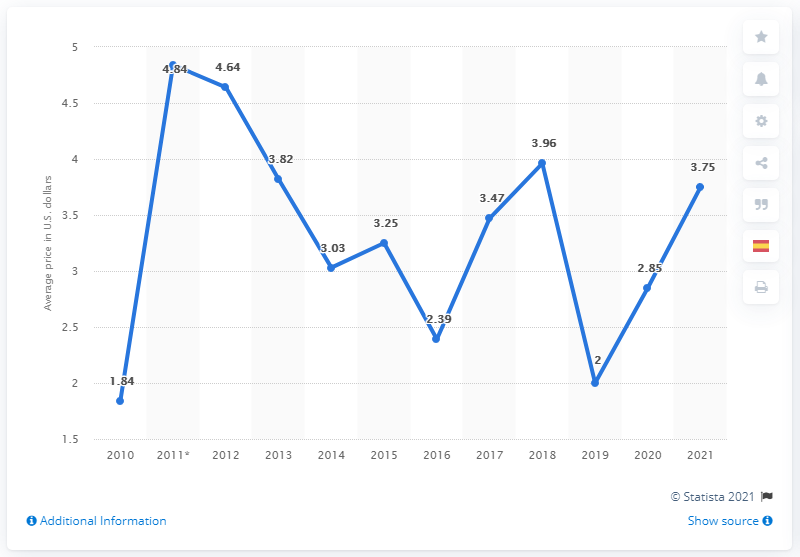Highlight a few significant elements in this photo. The average cost of a Big Mac burger in Argentina a year earlier was 2.85. In 2021, the average cost of a Big Mac burger in Argentina was 3.75. 